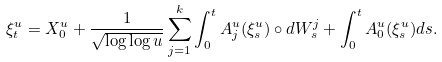<formula> <loc_0><loc_0><loc_500><loc_500>\xi ^ { u } _ { t } = X _ { 0 } ^ { u } + \frac { 1 } { \sqrt { \log \log u } } \sum _ { j = 1 } ^ { k } \int _ { 0 } ^ { t } A _ { j } ^ { u } ( \xi ^ { u } _ { s } ) \circ d W _ { s } ^ { j } + \int _ { 0 } ^ { t } A _ { 0 } ^ { u } ( \xi ^ { u } _ { s } ) d s .</formula> 